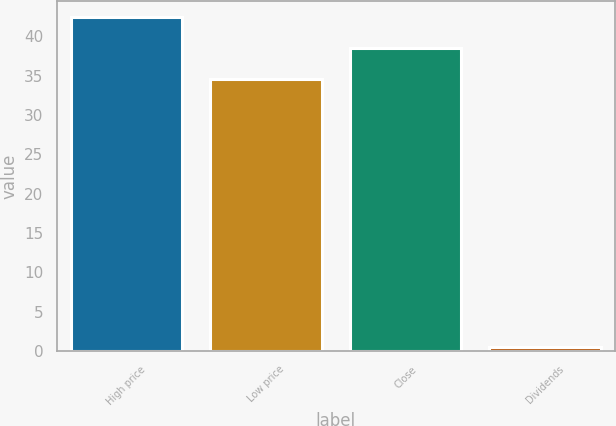Convert chart to OTSL. <chart><loc_0><loc_0><loc_500><loc_500><bar_chart><fcel>High price<fcel>Low price<fcel>Close<fcel>Dividends<nl><fcel>42.4<fcel>34.54<fcel>38.47<fcel>0.53<nl></chart> 